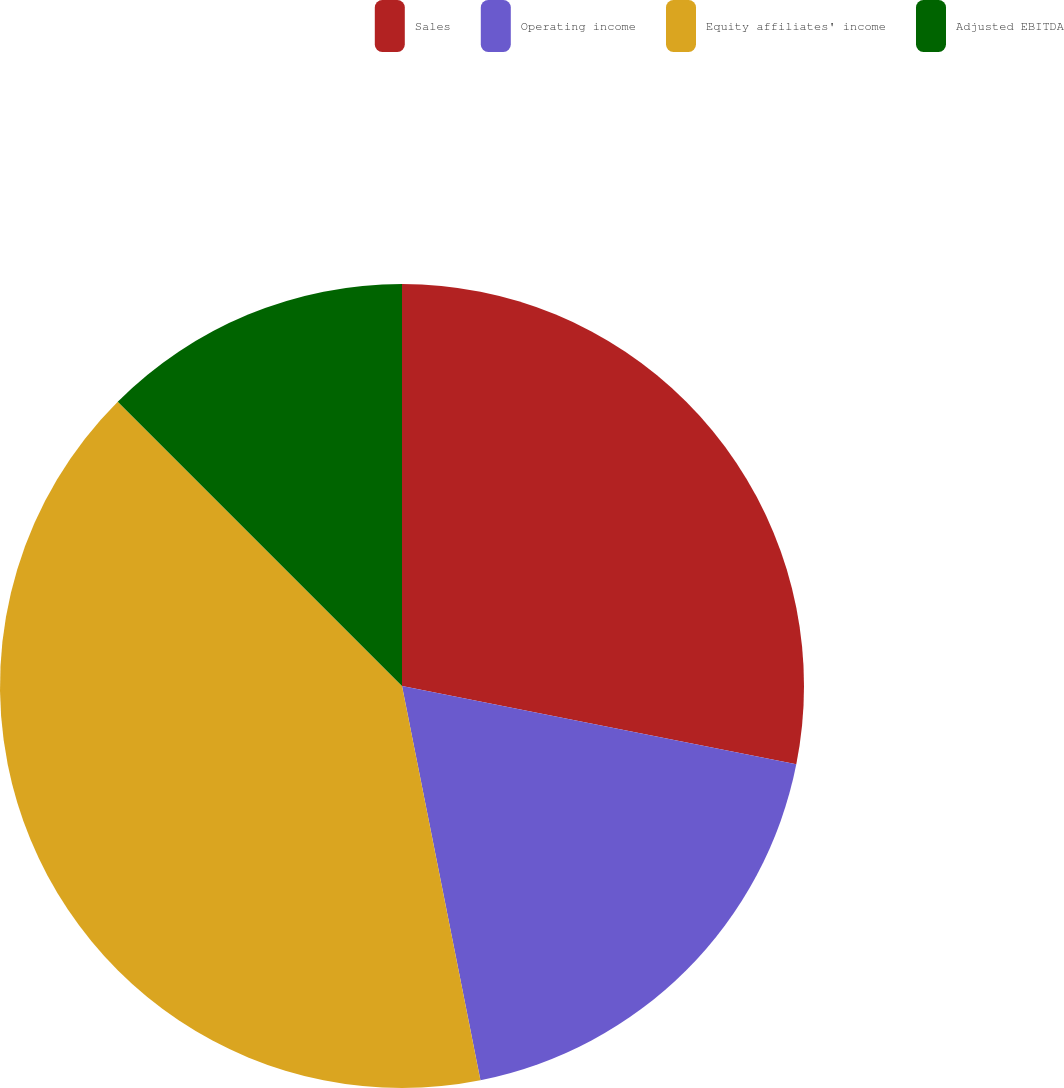<chart> <loc_0><loc_0><loc_500><loc_500><pie_chart><fcel>Sales<fcel>Operating income<fcel>Equity affiliates' income<fcel>Adjusted EBITDA<nl><fcel>28.12%<fcel>18.75%<fcel>40.62%<fcel>12.5%<nl></chart> 